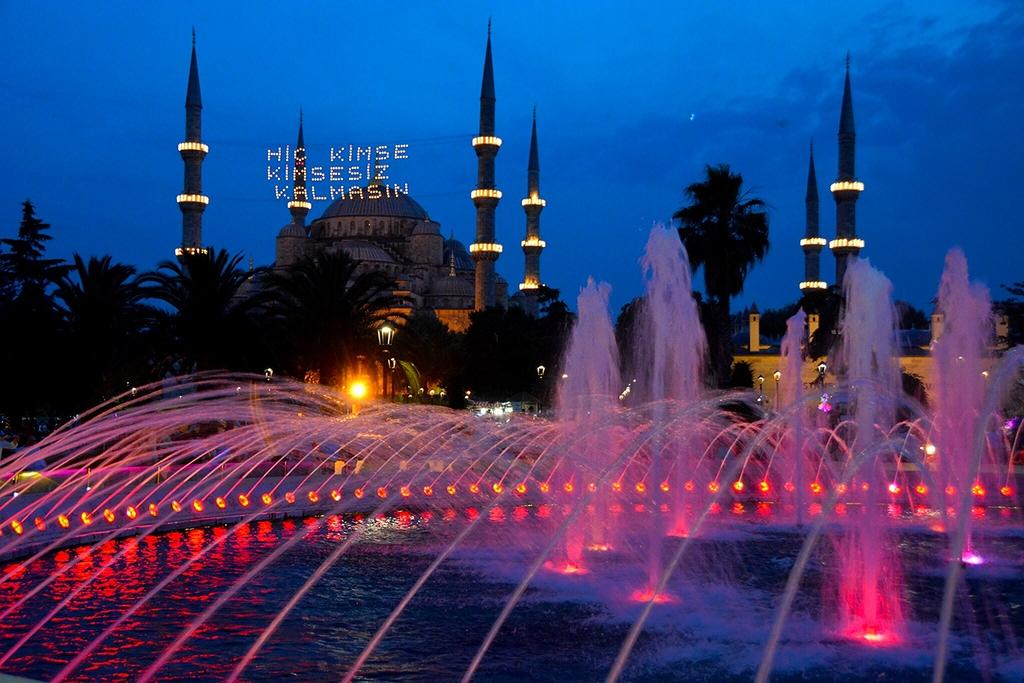What can be seen in the center of the image? There are buildings and trees in the center of the image. What is located at the bottom of the image? There is a fountain at the bottom of the image. What can be seen illuminating the area in the image? There are lights visible in the image. What is visible in the background of the image? The sky is visible in the background of the image. How many feet are visible in the image? There are no feet visible in the image. Can you see a banana in the image? There is no banana present in the image. 